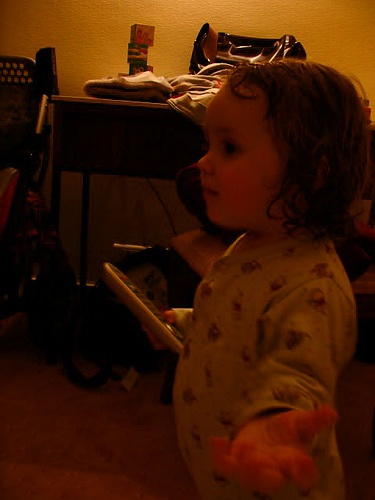Describe the objects in this image and their specific colors. I can see people in maroon, black, and brown tones, handbag in maroon, black, and olive tones, and remote in maroon and brown tones in this image. 